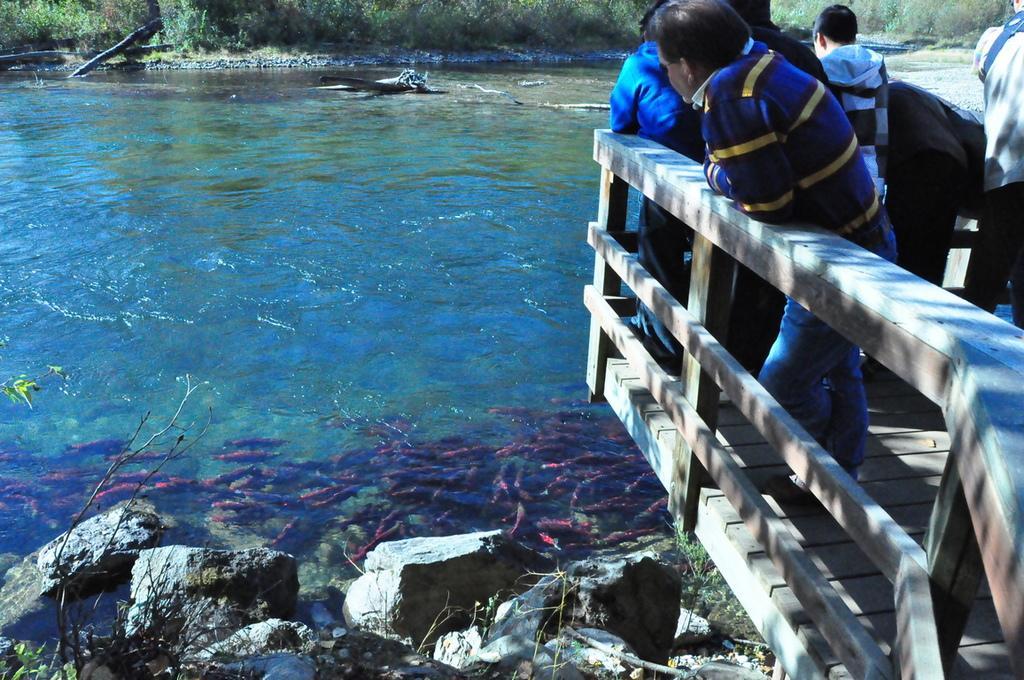Can you describe this image briefly? In this image I can see the group of people with different color dresses. I can see these people are standing to the side of the fence. To the side I can see the rocks and water. I can see the fish inside the water. In the background I can see many trees. 